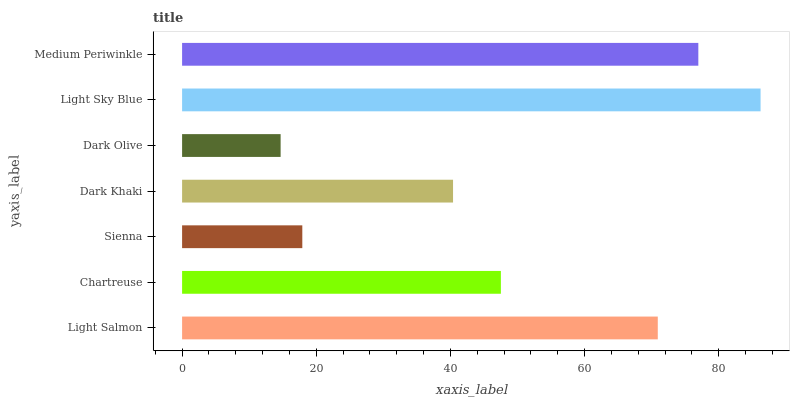Is Dark Olive the minimum?
Answer yes or no. Yes. Is Light Sky Blue the maximum?
Answer yes or no. Yes. Is Chartreuse the minimum?
Answer yes or no. No. Is Chartreuse the maximum?
Answer yes or no. No. Is Light Salmon greater than Chartreuse?
Answer yes or no. Yes. Is Chartreuse less than Light Salmon?
Answer yes or no. Yes. Is Chartreuse greater than Light Salmon?
Answer yes or no. No. Is Light Salmon less than Chartreuse?
Answer yes or no. No. Is Chartreuse the high median?
Answer yes or no. Yes. Is Chartreuse the low median?
Answer yes or no. Yes. Is Dark Olive the high median?
Answer yes or no. No. Is Light Sky Blue the low median?
Answer yes or no. No. 